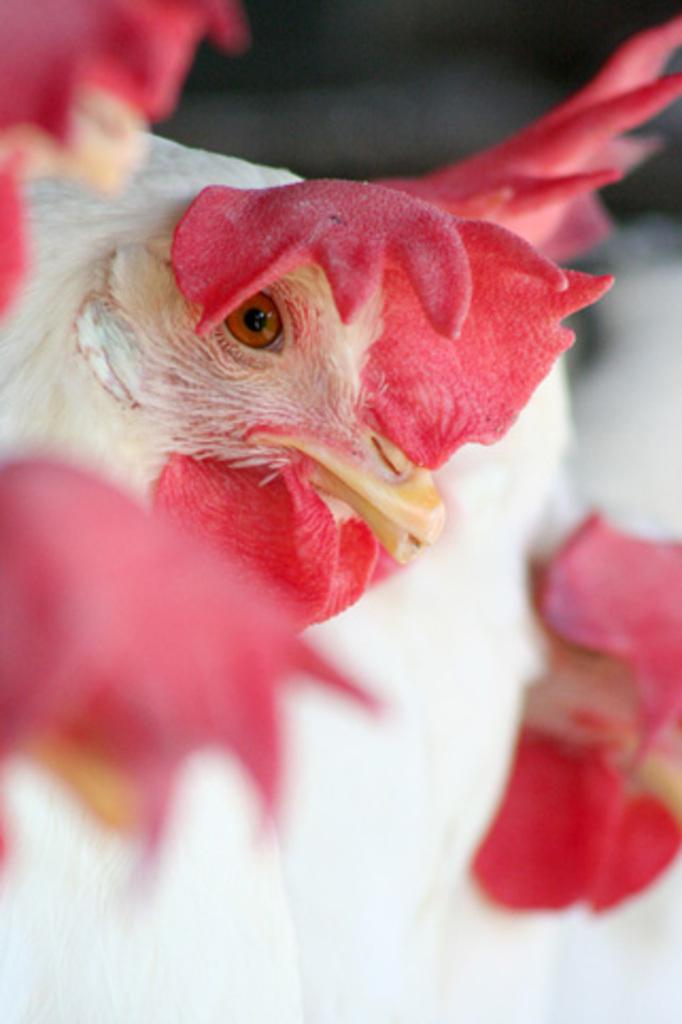What type of animals are in the image? Birds are in the image. How many legs can be seen on the birds in the image? The number of legs on the birds cannot be determined from the image, as the legs are not visible. What type of toothpaste is the bird using in the image? There is no toothpaste present in the image, as it features birds and birds do not use toothpaste. Can you see any toes on the birds in the image? The toes of the birds are not visible in the image, so it cannot be determined if any toes can be seen. 